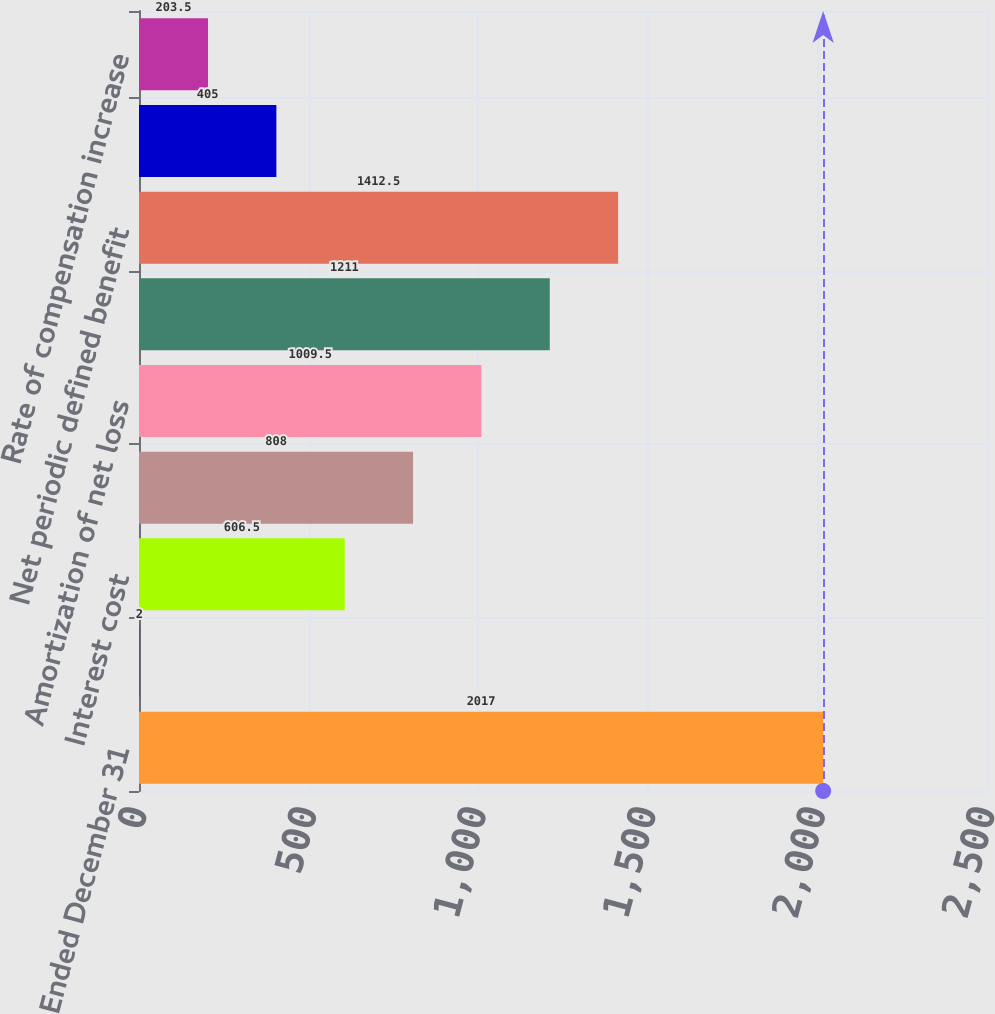Convert chart. <chart><loc_0><loc_0><loc_500><loc_500><bar_chart><fcel>Years Ended December 31<fcel>Service cost (a)<fcel>Interest cost<fcel>Amortization of prior service<fcel>Amortization of net loss<fcel>Total other components of net<fcel>Net periodic defined benefit<fcel>Discount rate<fcel>Rate of compensation increase<nl><fcel>2017<fcel>2<fcel>606.5<fcel>808<fcel>1009.5<fcel>1211<fcel>1412.5<fcel>405<fcel>203.5<nl></chart> 